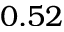Convert formula to latex. <formula><loc_0><loc_0><loc_500><loc_500>0 . 5 2</formula> 